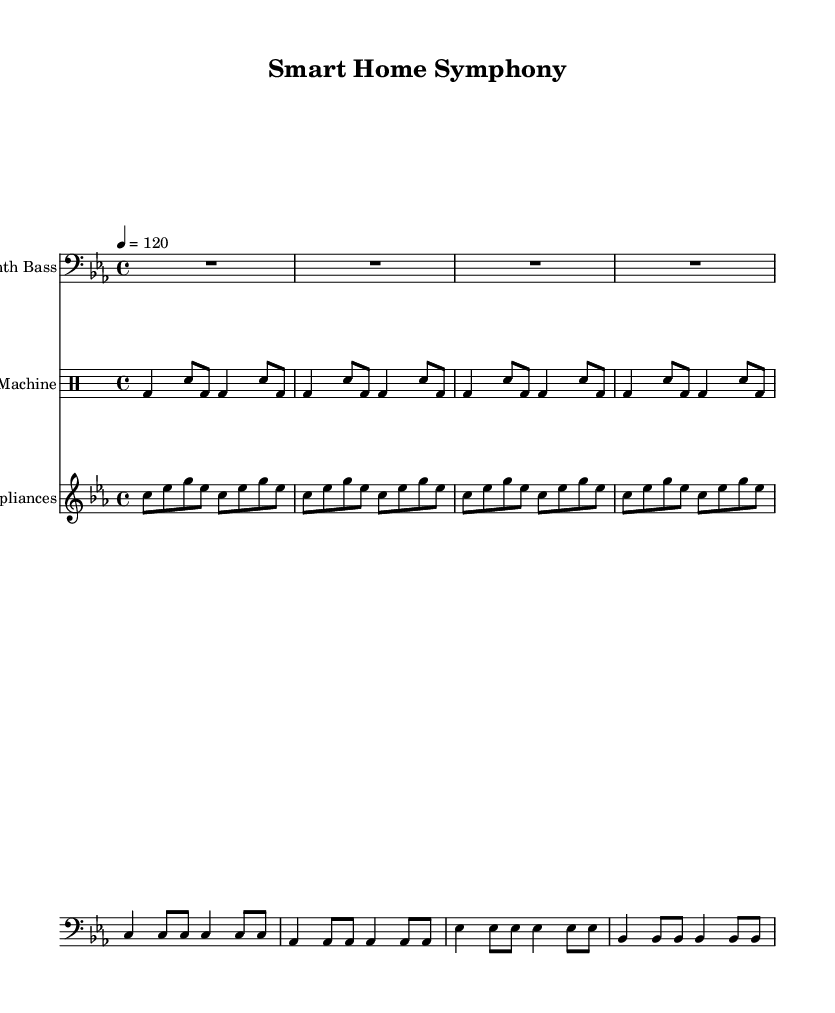What is the key signature of this music? The key signature is C minor, which is indicated by three flats (B♭, E♭, A♭). This is determined by looking for the key signature indicated at the beginning of the score.
Answer: C minor What is the time signature of this piece? The time signature is 4/4, noted at the beginning of the score. The top number indicates that there are four beats in a measure, and the bottom number tells us that the quarter note gets one beat.
Answer: 4/4 What is the tempo marking for this music? The tempo marking is 120 beats per minute, shown in the tempo directive "4 = 120" at the start. This indicates the speed at which the piece should be played.
Answer: 120 How many measures are there for the Synth Bass part? Counting the number of distinct groups of notes separated by vertical lines (bar lines) reveals there are 8 measures for the Synth Bass part. Each section of music from one bar line to the next is considered a measure.
Answer: 8 What type of instrument is used for the Drum Machine part? The Drum Machine part is specified within a "DrumStaff" context, indicating that it is designed for percussion instruments, commonly found in electronic music.
Answer: Drum Machine How many different notes are included in the Sampled Appliances section? The notes in the Sampled Appliances section are repeated patterns of C, E♭, and G, totaling 3 distinct notes. Observing the pitches used indicates the variation of these three notes plays throughout the section.
Answer: 3 